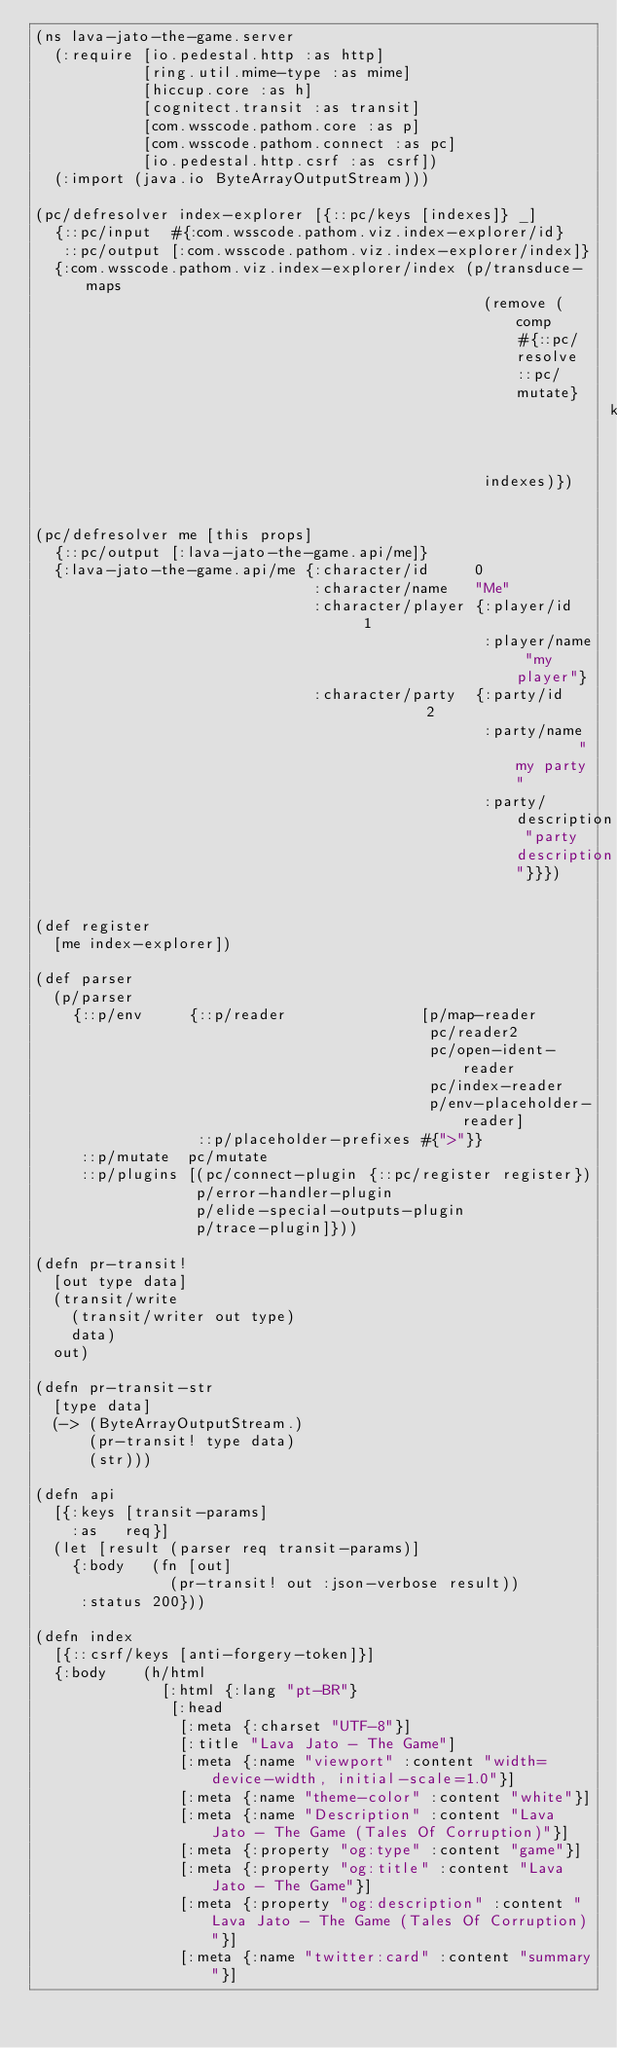Convert code to text. <code><loc_0><loc_0><loc_500><loc_500><_Clojure_>(ns lava-jato-the-game.server
  (:require [io.pedestal.http :as http]
            [ring.util.mime-type :as mime]
            [hiccup.core :as h]
            [cognitect.transit :as transit]
            [com.wsscode.pathom.core :as p]
            [com.wsscode.pathom.connect :as pc]
            [io.pedestal.http.csrf :as csrf])
  (:import (java.io ByteArrayOutputStream)))

(pc/defresolver index-explorer [{::pc/keys [indexes]} _]
  {::pc/input  #{:com.wsscode.pathom.viz.index-explorer/id}
   ::pc/output [:com.wsscode.pathom.viz.index-explorer/index]}
  {:com.wsscode.pathom.viz.index-explorer/index (p/transduce-maps
                                                  (remove (comp #{::pc/resolve ::pc/mutate}
                                                                key))
                                                  indexes)})


(pc/defresolver me [this props]
  {::pc/output [:lava-jato-the-game.api/me]}
  {:lava-jato-the-game.api/me {:character/id     0
                               :character/name   "Me"
                               :character/player {:player/id   1
                                                  :player/name "my player"}
                               :character/party  {:party/id          2
                                                  :party/name        "my party"
                                                  :party/description "party description"}}})


(def register
  [me index-explorer])

(def parser
  (p/parser
    {::p/env     {::p/reader               [p/map-reader
                                            pc/reader2
                                            pc/open-ident-reader
                                            pc/index-reader
                                            p/env-placeholder-reader]
                  ::p/placeholder-prefixes #{">"}}
     ::p/mutate  pc/mutate
     ::p/plugins [(pc/connect-plugin {::pc/register register})
                  p/error-handler-plugin
                  p/elide-special-outputs-plugin
                  p/trace-plugin]}))

(defn pr-transit!
  [out type data]
  (transit/write
    (transit/writer out type)
    data)
  out)

(defn pr-transit-str
  [type data]
  (-> (ByteArrayOutputStream.)
      (pr-transit! type data)
      (str)))

(defn api
  [{:keys [transit-params]
    :as   req}]
  (let [result (parser req transit-params)]
    {:body   (fn [out]
               (pr-transit! out :json-verbose result))
     :status 200}))

(defn index
  [{::csrf/keys [anti-forgery-token]}]
  {:body    (h/html
              [:html {:lang "pt-BR"}
               [:head
                [:meta {:charset "UTF-8"}]
                [:title "Lava Jato - The Game"]
                [:meta {:name "viewport" :content "width=device-width, initial-scale=1.0"}]
                [:meta {:name "theme-color" :content "white"}]
                [:meta {:name "Description" :content "Lava Jato - The Game (Tales Of Corruption)"}]
                [:meta {:property "og:type" :content "game"}]
                [:meta {:property "og:title" :content "Lava Jato - The Game"}]
                [:meta {:property "og:description" :content "Lava Jato - The Game (Tales Of Corruption)"}]
                [:meta {:name "twitter:card" :content "summary"}]</code> 